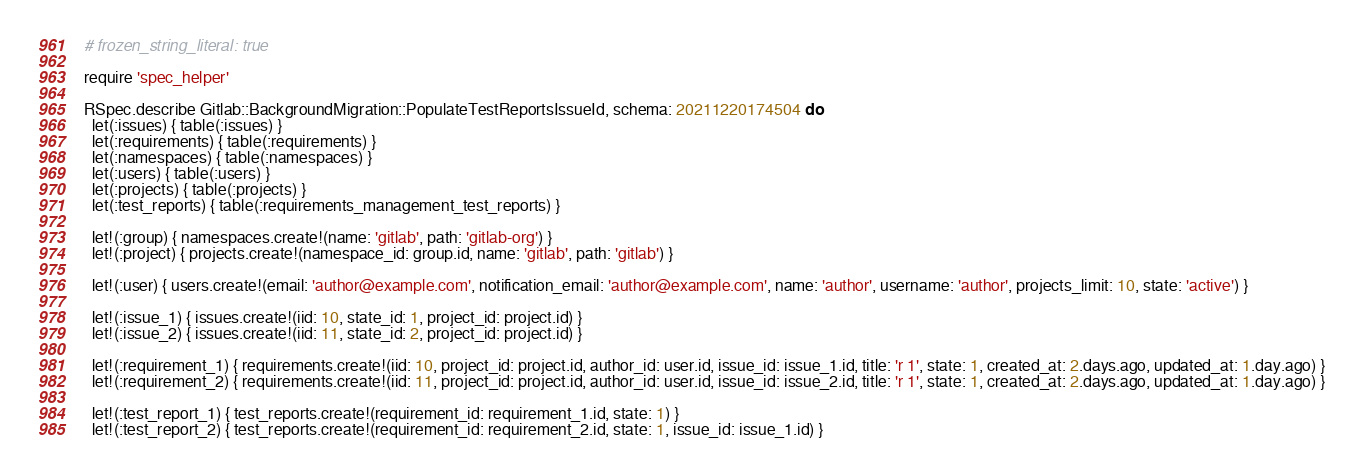Convert code to text. <code><loc_0><loc_0><loc_500><loc_500><_Ruby_># frozen_string_literal: true

require 'spec_helper'

RSpec.describe Gitlab::BackgroundMigration::PopulateTestReportsIssueId, schema: 20211220174504 do
  let(:issues) { table(:issues) }
  let(:requirements) { table(:requirements) }
  let(:namespaces) { table(:namespaces) }
  let(:users) { table(:users) }
  let(:projects) { table(:projects) }
  let(:test_reports) { table(:requirements_management_test_reports) }

  let!(:group) { namespaces.create!(name: 'gitlab', path: 'gitlab-org') }
  let!(:project) { projects.create!(namespace_id: group.id, name: 'gitlab', path: 'gitlab') }

  let!(:user) { users.create!(email: 'author@example.com', notification_email: 'author@example.com', name: 'author', username: 'author', projects_limit: 10, state: 'active') }

  let!(:issue_1) { issues.create!(iid: 10, state_id: 1, project_id: project.id) }
  let!(:issue_2) { issues.create!(iid: 11, state_id: 2, project_id: project.id) }

  let!(:requirement_1) { requirements.create!(iid: 10, project_id: project.id, author_id: user.id, issue_id: issue_1.id, title: 'r 1', state: 1, created_at: 2.days.ago, updated_at: 1.day.ago) }
  let!(:requirement_2) { requirements.create!(iid: 11, project_id: project.id, author_id: user.id, issue_id: issue_2.id, title: 'r 1', state: 1, created_at: 2.days.ago, updated_at: 1.day.ago) }

  let!(:test_report_1) { test_reports.create!(requirement_id: requirement_1.id, state: 1) }
  let!(:test_report_2) { test_reports.create!(requirement_id: requirement_2.id, state: 1, issue_id: issue_1.id) }</code> 